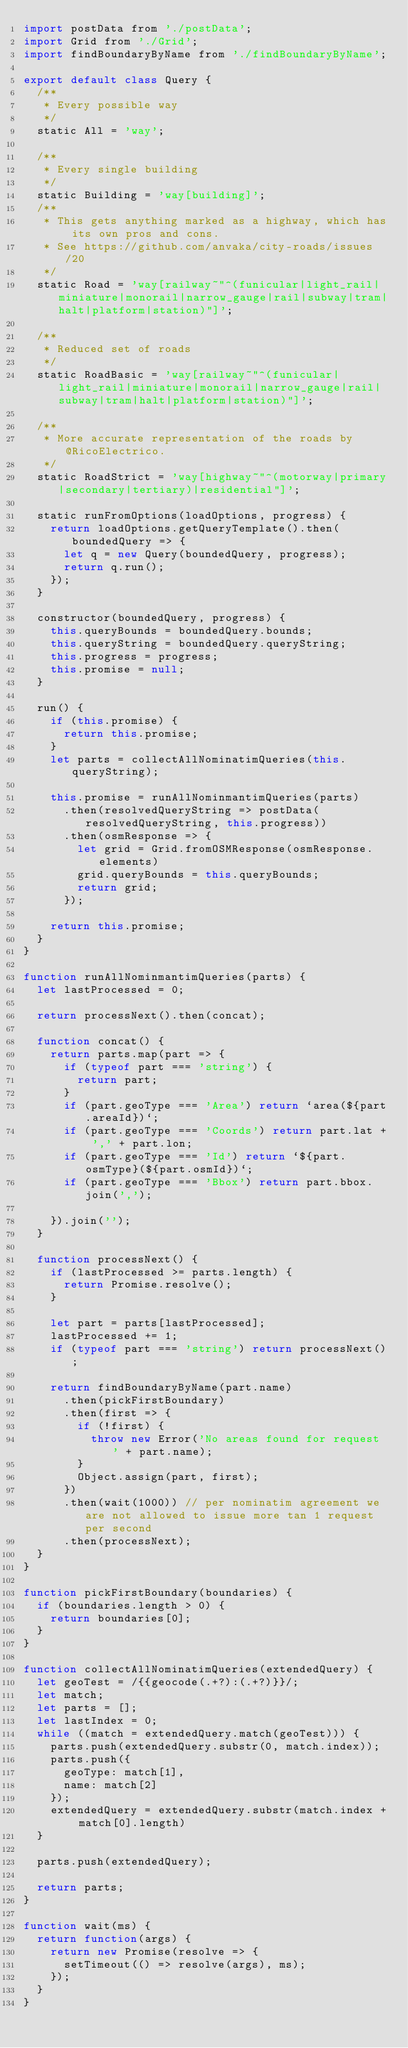<code> <loc_0><loc_0><loc_500><loc_500><_JavaScript_>import postData from './postData';
import Grid from './Grid';
import findBoundaryByName from './findBoundaryByName';

export default class Query {
  /**
   * Every possible way
   */
  static All = 'way';

  /**
   * Every single building
   */
  static Building = 'way[building]';
  /**
   * This gets anything marked as a highway, which has its own pros and cons.
   * See https://github.com/anvaka/city-roads/issues/20
   */
  static Road = 'way[railway~"^(funicular|light_rail|miniature|monorail|narrow_gauge|rail|subway|tram|halt|platform|station)"]';

  /**
   * Reduced set of roads
   */
  static RoadBasic = 'way[railway~"^(funicular|light_rail|miniature|monorail|narrow_gauge|rail|subway|tram|halt|platform|station)"]';

  /**
   * More accurate representation of the roads by @RicoElectrico.
   */
  static RoadStrict = 'way[highway~"^(motorway|primary|secondary|tertiary)|residential"]';

  static runFromOptions(loadOptions, progress) {
    return loadOptions.getQueryTemplate().then(boundedQuery => {
      let q = new Query(boundedQuery, progress);
      return q.run();
    });
  }

  constructor(boundedQuery, progress) {
    this.queryBounds = boundedQuery.bounds;
    this.queryString = boundedQuery.queryString;
    this.progress = progress;
    this.promise = null;
  }

  run() {
    if (this.promise) {
      return this.promise;
    }
    let parts = collectAllNominatimQueries(this.queryString);

    this.promise = runAllNominmantimQueries(parts)
      .then(resolvedQueryString => postData(resolvedQueryString, this.progress))
      .then(osmResponse => {
        let grid = Grid.fromOSMResponse(osmResponse.elements)
        grid.queryBounds = this.queryBounds;
        return grid;
      });

    return this.promise;
  }
}

function runAllNominmantimQueries(parts) {
  let lastProcessed = 0;

  return processNext().then(concat);

  function concat() {
    return parts.map(part => {
      if (typeof part === 'string') {
        return part;
      } 
      if (part.geoType === 'Area') return `area(${part.areaId})`;
      if (part.geoType === 'Coords') return part.lat + ',' + part.lon;
      if (part.geoType === 'Id') return `${part.osmType}(${part.osmId})`;
      if (part.geoType === 'Bbox') return part.bbox.join(',');
 
    }).join('');
  }
  
  function processNext() {
    if (lastProcessed >= parts.length) {
      return Promise.resolve();
    }
    
    let part = parts[lastProcessed];
    lastProcessed += 1;
    if (typeof part === 'string') return processNext();

    return findBoundaryByName(part.name)
      .then(pickFirstBoundary)
      .then(first => {
        if (!first) {
          throw new Error('No areas found for request ' + part.name);
        }
        Object.assign(part, first);
      })
      .then(wait(1000)) // per nominatim agreement we are not allowed to issue more tan 1 request per second
      .then(processNext);
  }
}

function pickFirstBoundary(boundaries) {
  if (boundaries.length > 0) {
    return boundaries[0];
  }
}

function collectAllNominatimQueries(extendedQuery) {
  let geoTest = /{{geocode(.+?):(.+?)}}/;
  let match;
  let parts = [];
  let lastIndex = 0;
  while ((match = extendedQuery.match(geoTest))) {
    parts.push(extendedQuery.substr(0, match.index));
    parts.push({
      geoType: match[1],
      name: match[2]
    });
    extendedQuery = extendedQuery.substr(match.index + match[0].length)
  }

  parts.push(extendedQuery);

  return parts;
}

function wait(ms) {
  return function(args) {
    return new Promise(resolve => {
      setTimeout(() => resolve(args), ms);
    });
  }
}

</code> 